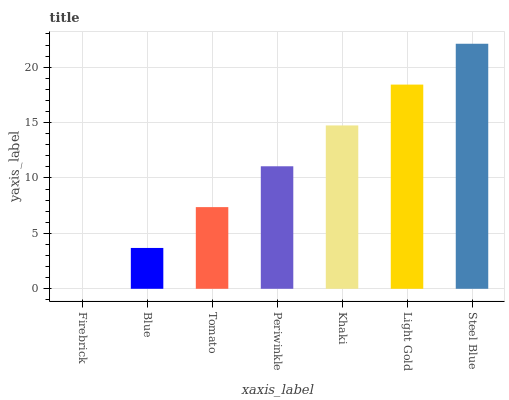Is Firebrick the minimum?
Answer yes or no. Yes. Is Steel Blue the maximum?
Answer yes or no. Yes. Is Blue the minimum?
Answer yes or no. No. Is Blue the maximum?
Answer yes or no. No. Is Blue greater than Firebrick?
Answer yes or no. Yes. Is Firebrick less than Blue?
Answer yes or no. Yes. Is Firebrick greater than Blue?
Answer yes or no. No. Is Blue less than Firebrick?
Answer yes or no. No. Is Periwinkle the high median?
Answer yes or no. Yes. Is Periwinkle the low median?
Answer yes or no. Yes. Is Khaki the high median?
Answer yes or no. No. Is Tomato the low median?
Answer yes or no. No. 